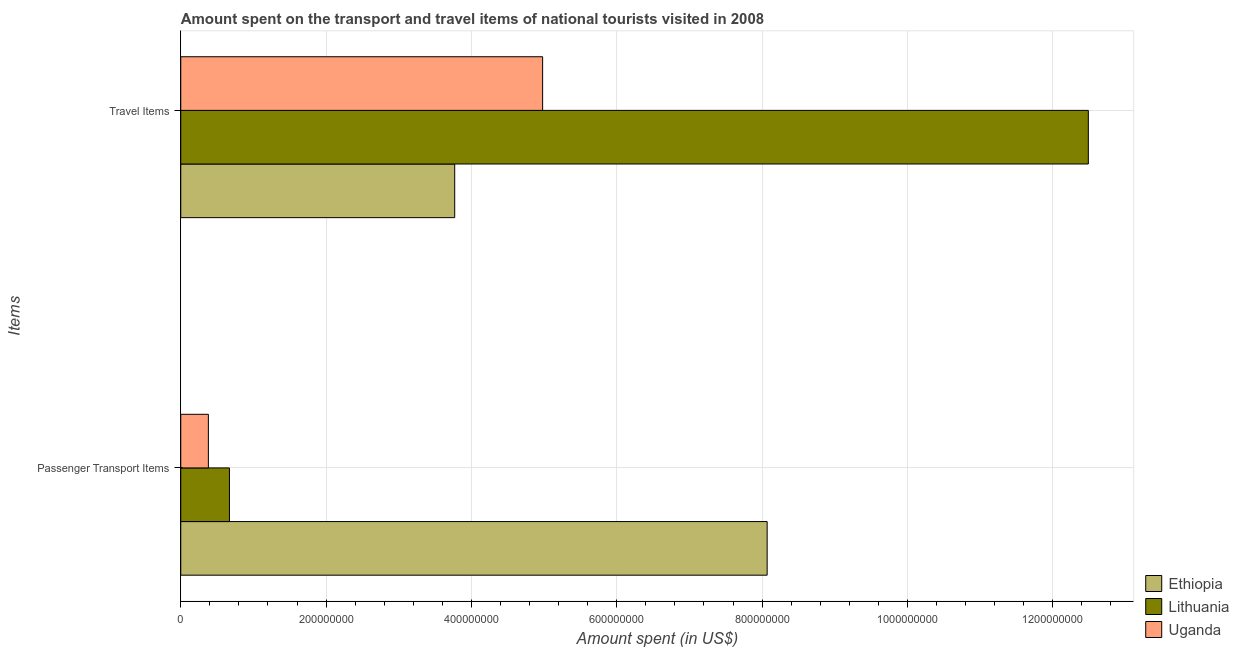Are the number of bars per tick equal to the number of legend labels?
Offer a very short reply. Yes. Are the number of bars on each tick of the Y-axis equal?
Make the answer very short. Yes. How many bars are there on the 2nd tick from the top?
Keep it short and to the point. 3. How many bars are there on the 2nd tick from the bottom?
Your answer should be very brief. 3. What is the label of the 1st group of bars from the top?
Give a very brief answer. Travel Items. What is the amount spent in travel items in Uganda?
Provide a succinct answer. 4.98e+08. Across all countries, what is the maximum amount spent on passenger transport items?
Offer a terse response. 8.07e+08. Across all countries, what is the minimum amount spent in travel items?
Your answer should be compact. 3.77e+08. In which country was the amount spent in travel items maximum?
Your answer should be very brief. Lithuania. In which country was the amount spent in travel items minimum?
Offer a very short reply. Ethiopia. What is the total amount spent in travel items in the graph?
Your answer should be compact. 2.12e+09. What is the difference between the amount spent in travel items in Lithuania and that in Ethiopia?
Provide a short and direct response. 8.72e+08. What is the difference between the amount spent in travel items in Uganda and the amount spent on passenger transport items in Lithuania?
Ensure brevity in your answer.  4.31e+08. What is the average amount spent in travel items per country?
Provide a succinct answer. 7.08e+08. What is the difference between the amount spent in travel items and amount spent on passenger transport items in Uganda?
Ensure brevity in your answer.  4.60e+08. What is the ratio of the amount spent in travel items in Uganda to that in Ethiopia?
Provide a succinct answer. 1.32. Is the amount spent in travel items in Lithuania less than that in Uganda?
Provide a succinct answer. No. In how many countries, is the amount spent in travel items greater than the average amount spent in travel items taken over all countries?
Offer a very short reply. 1. What does the 1st bar from the top in Passenger Transport Items represents?
Offer a very short reply. Uganda. What does the 2nd bar from the bottom in Passenger Transport Items represents?
Give a very brief answer. Lithuania. How many bars are there?
Offer a very short reply. 6. What is the difference between two consecutive major ticks on the X-axis?
Provide a succinct answer. 2.00e+08. Are the values on the major ticks of X-axis written in scientific E-notation?
Give a very brief answer. No. Does the graph contain any zero values?
Provide a succinct answer. No. What is the title of the graph?
Your response must be concise. Amount spent on the transport and travel items of national tourists visited in 2008. What is the label or title of the X-axis?
Provide a succinct answer. Amount spent (in US$). What is the label or title of the Y-axis?
Offer a terse response. Items. What is the Amount spent (in US$) of Ethiopia in Passenger Transport Items?
Ensure brevity in your answer.  8.07e+08. What is the Amount spent (in US$) of Lithuania in Passenger Transport Items?
Give a very brief answer. 6.70e+07. What is the Amount spent (in US$) of Uganda in Passenger Transport Items?
Ensure brevity in your answer.  3.80e+07. What is the Amount spent (in US$) of Ethiopia in Travel Items?
Make the answer very short. 3.77e+08. What is the Amount spent (in US$) of Lithuania in Travel Items?
Your answer should be compact. 1.25e+09. What is the Amount spent (in US$) in Uganda in Travel Items?
Provide a short and direct response. 4.98e+08. Across all Items, what is the maximum Amount spent (in US$) of Ethiopia?
Your answer should be compact. 8.07e+08. Across all Items, what is the maximum Amount spent (in US$) in Lithuania?
Offer a terse response. 1.25e+09. Across all Items, what is the maximum Amount spent (in US$) of Uganda?
Your answer should be compact. 4.98e+08. Across all Items, what is the minimum Amount spent (in US$) of Ethiopia?
Your response must be concise. 3.77e+08. Across all Items, what is the minimum Amount spent (in US$) of Lithuania?
Keep it short and to the point. 6.70e+07. Across all Items, what is the minimum Amount spent (in US$) of Uganda?
Offer a very short reply. 3.80e+07. What is the total Amount spent (in US$) of Ethiopia in the graph?
Provide a short and direct response. 1.18e+09. What is the total Amount spent (in US$) in Lithuania in the graph?
Offer a terse response. 1.32e+09. What is the total Amount spent (in US$) in Uganda in the graph?
Make the answer very short. 5.36e+08. What is the difference between the Amount spent (in US$) of Ethiopia in Passenger Transport Items and that in Travel Items?
Give a very brief answer. 4.30e+08. What is the difference between the Amount spent (in US$) of Lithuania in Passenger Transport Items and that in Travel Items?
Make the answer very short. -1.18e+09. What is the difference between the Amount spent (in US$) of Uganda in Passenger Transport Items and that in Travel Items?
Your response must be concise. -4.60e+08. What is the difference between the Amount spent (in US$) of Ethiopia in Passenger Transport Items and the Amount spent (in US$) of Lithuania in Travel Items?
Your response must be concise. -4.42e+08. What is the difference between the Amount spent (in US$) of Ethiopia in Passenger Transport Items and the Amount spent (in US$) of Uganda in Travel Items?
Offer a very short reply. 3.09e+08. What is the difference between the Amount spent (in US$) in Lithuania in Passenger Transport Items and the Amount spent (in US$) in Uganda in Travel Items?
Your answer should be compact. -4.31e+08. What is the average Amount spent (in US$) in Ethiopia per Items?
Provide a succinct answer. 5.92e+08. What is the average Amount spent (in US$) of Lithuania per Items?
Keep it short and to the point. 6.58e+08. What is the average Amount spent (in US$) in Uganda per Items?
Keep it short and to the point. 2.68e+08. What is the difference between the Amount spent (in US$) of Ethiopia and Amount spent (in US$) of Lithuania in Passenger Transport Items?
Provide a short and direct response. 7.40e+08. What is the difference between the Amount spent (in US$) of Ethiopia and Amount spent (in US$) of Uganda in Passenger Transport Items?
Provide a succinct answer. 7.69e+08. What is the difference between the Amount spent (in US$) of Lithuania and Amount spent (in US$) of Uganda in Passenger Transport Items?
Offer a very short reply. 2.90e+07. What is the difference between the Amount spent (in US$) in Ethiopia and Amount spent (in US$) in Lithuania in Travel Items?
Give a very brief answer. -8.72e+08. What is the difference between the Amount spent (in US$) in Ethiopia and Amount spent (in US$) in Uganda in Travel Items?
Give a very brief answer. -1.21e+08. What is the difference between the Amount spent (in US$) in Lithuania and Amount spent (in US$) in Uganda in Travel Items?
Your response must be concise. 7.51e+08. What is the ratio of the Amount spent (in US$) of Ethiopia in Passenger Transport Items to that in Travel Items?
Offer a terse response. 2.14. What is the ratio of the Amount spent (in US$) in Lithuania in Passenger Transport Items to that in Travel Items?
Offer a terse response. 0.05. What is the ratio of the Amount spent (in US$) of Uganda in Passenger Transport Items to that in Travel Items?
Offer a terse response. 0.08. What is the difference between the highest and the second highest Amount spent (in US$) of Ethiopia?
Offer a terse response. 4.30e+08. What is the difference between the highest and the second highest Amount spent (in US$) in Lithuania?
Ensure brevity in your answer.  1.18e+09. What is the difference between the highest and the second highest Amount spent (in US$) of Uganda?
Provide a succinct answer. 4.60e+08. What is the difference between the highest and the lowest Amount spent (in US$) in Ethiopia?
Your answer should be compact. 4.30e+08. What is the difference between the highest and the lowest Amount spent (in US$) in Lithuania?
Provide a short and direct response. 1.18e+09. What is the difference between the highest and the lowest Amount spent (in US$) in Uganda?
Provide a succinct answer. 4.60e+08. 